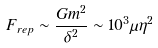Convert formula to latex. <formula><loc_0><loc_0><loc_500><loc_500>F _ { r e p } \sim \frac { G m ^ { 2 } } { \delta ^ { 2 } } \sim 1 0 ^ { 3 } \mu \eta ^ { 2 }</formula> 